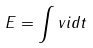<formula> <loc_0><loc_0><loc_500><loc_500>E = \int v i d t</formula> 